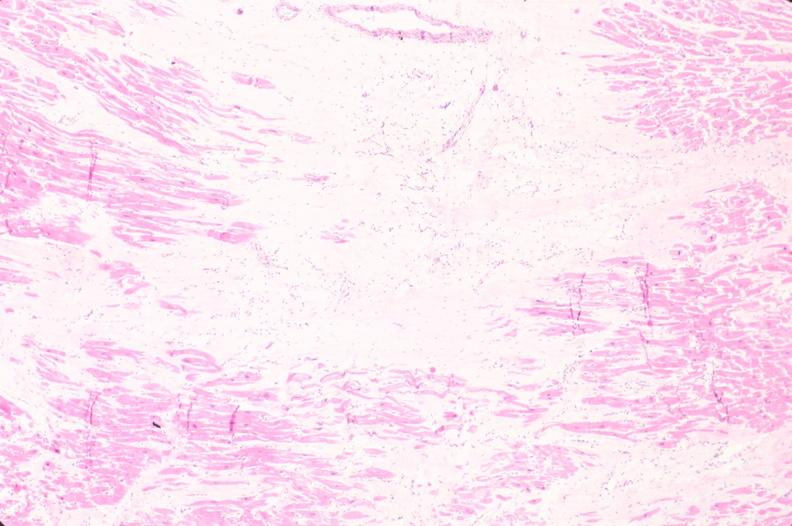does this image show heart, old myocardial infarction with fibrosis, he?
Answer the question using a single word or phrase. Yes 